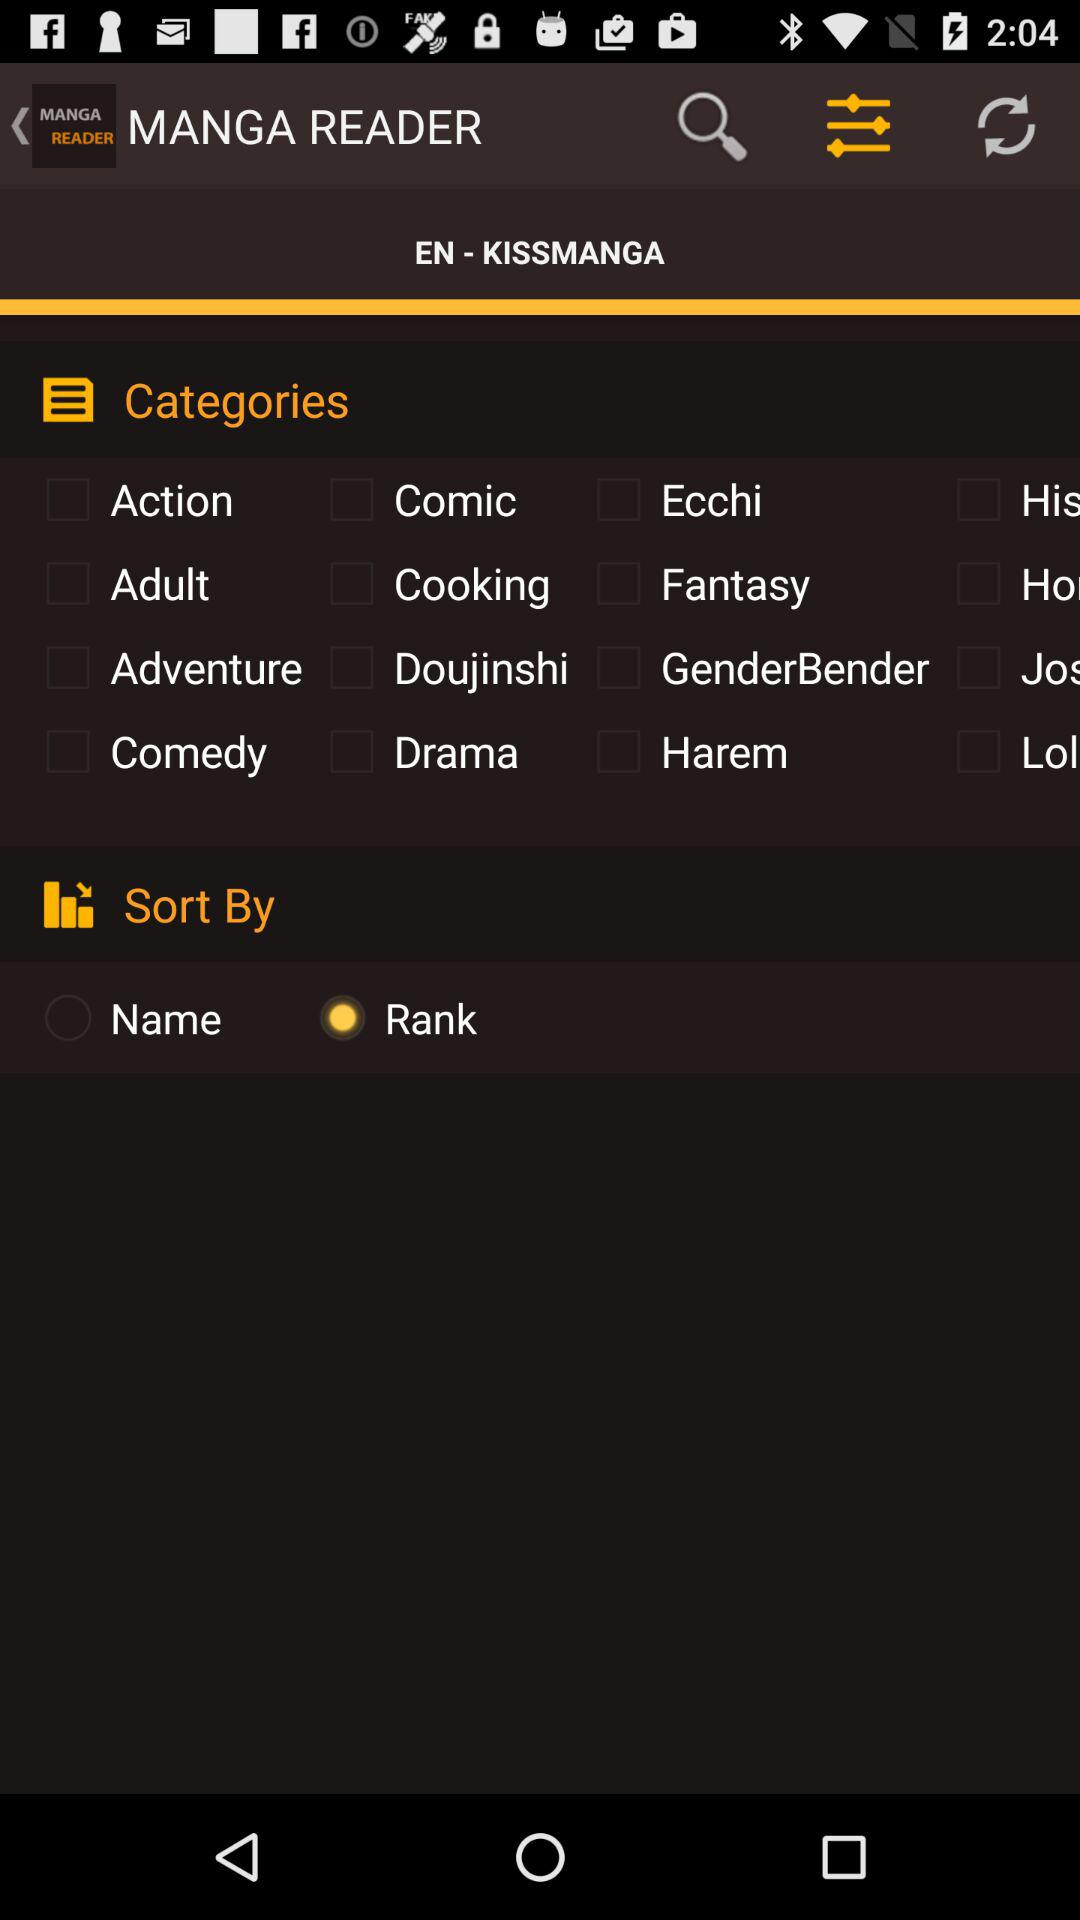Which option is selected in "Sort by"? The selected option in "Sort by" is "Rank". 